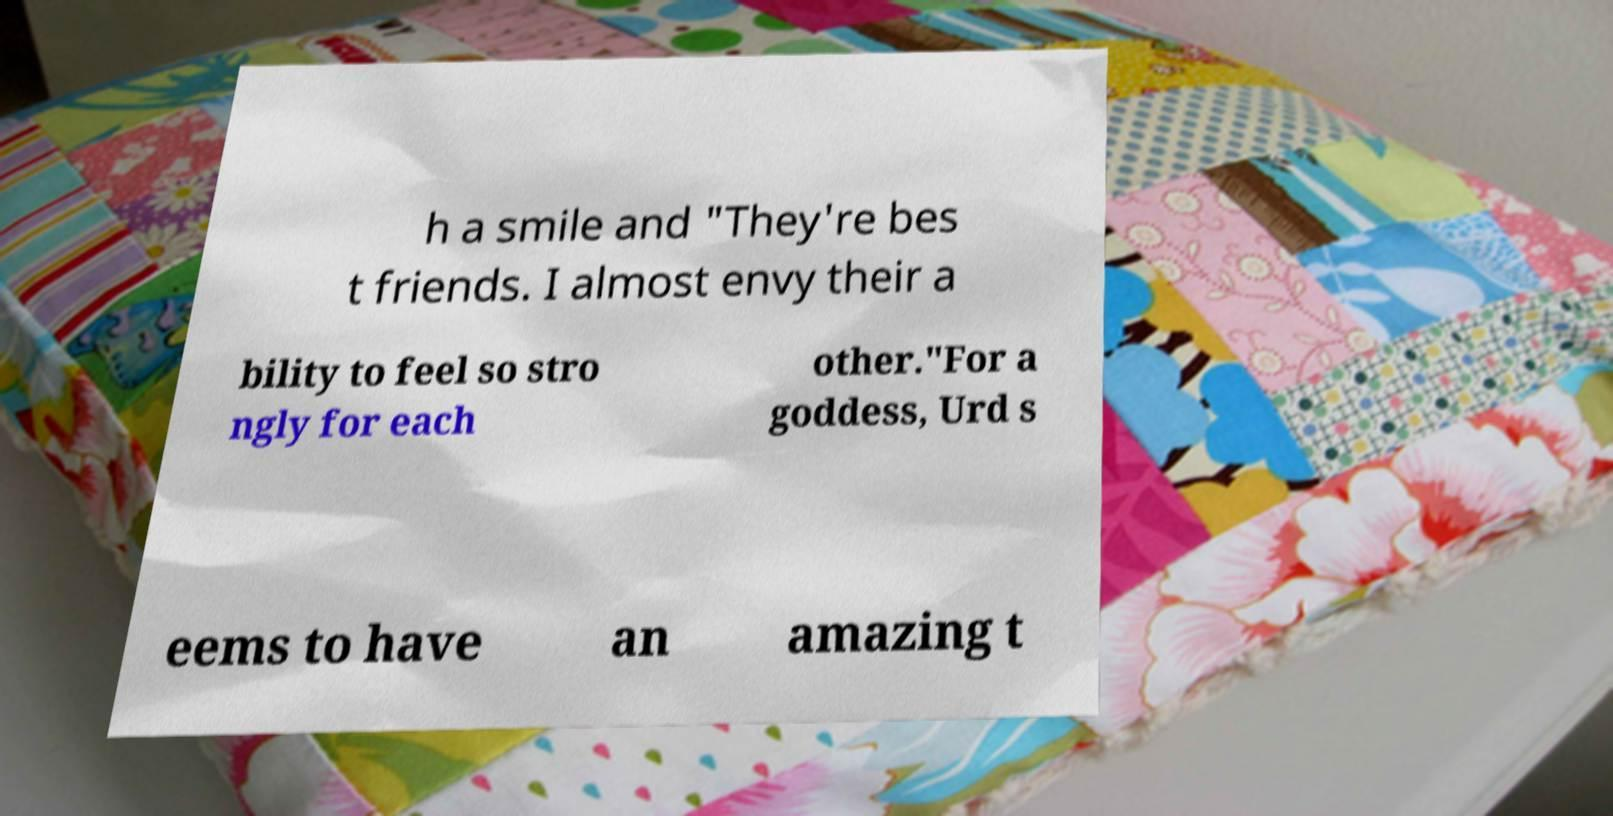Can you read and provide the text displayed in the image?This photo seems to have some interesting text. Can you extract and type it out for me? h a smile and "They're bes t friends. I almost envy their a bility to feel so stro ngly for each other."For a goddess, Urd s eems to have an amazing t 